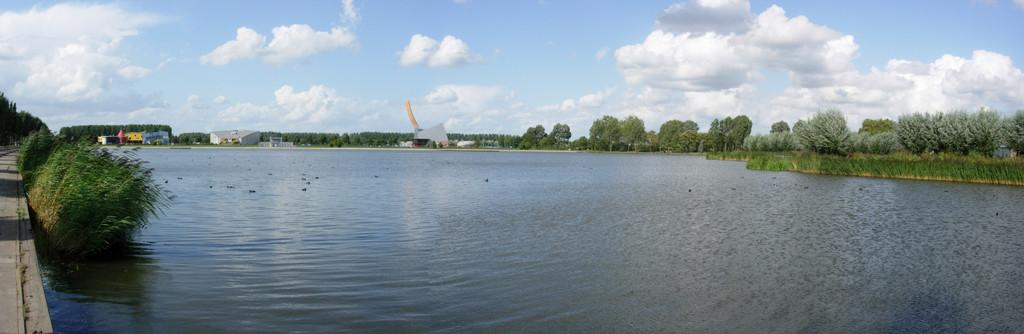What is visible in the image? Water, plants, trees, buildings, a path, and the sky are visible in the image. Can you describe the vegetation in the image? There are plants and trees in the image. What type of man-made structures can be seen in the image? There are buildings in the image. Is there a path for people to walk on in the image? Yes, there is a path in the image. What can be seen in the background of the image? The sky is visible in the background of the image. What type of produce is being sold at the sidewalk market in the image? There is no sidewalk market or produce present in the image. What type of building is shown in the image? The image contains multiple buildings, but no specific type of building is mentioned in the provided facts. 